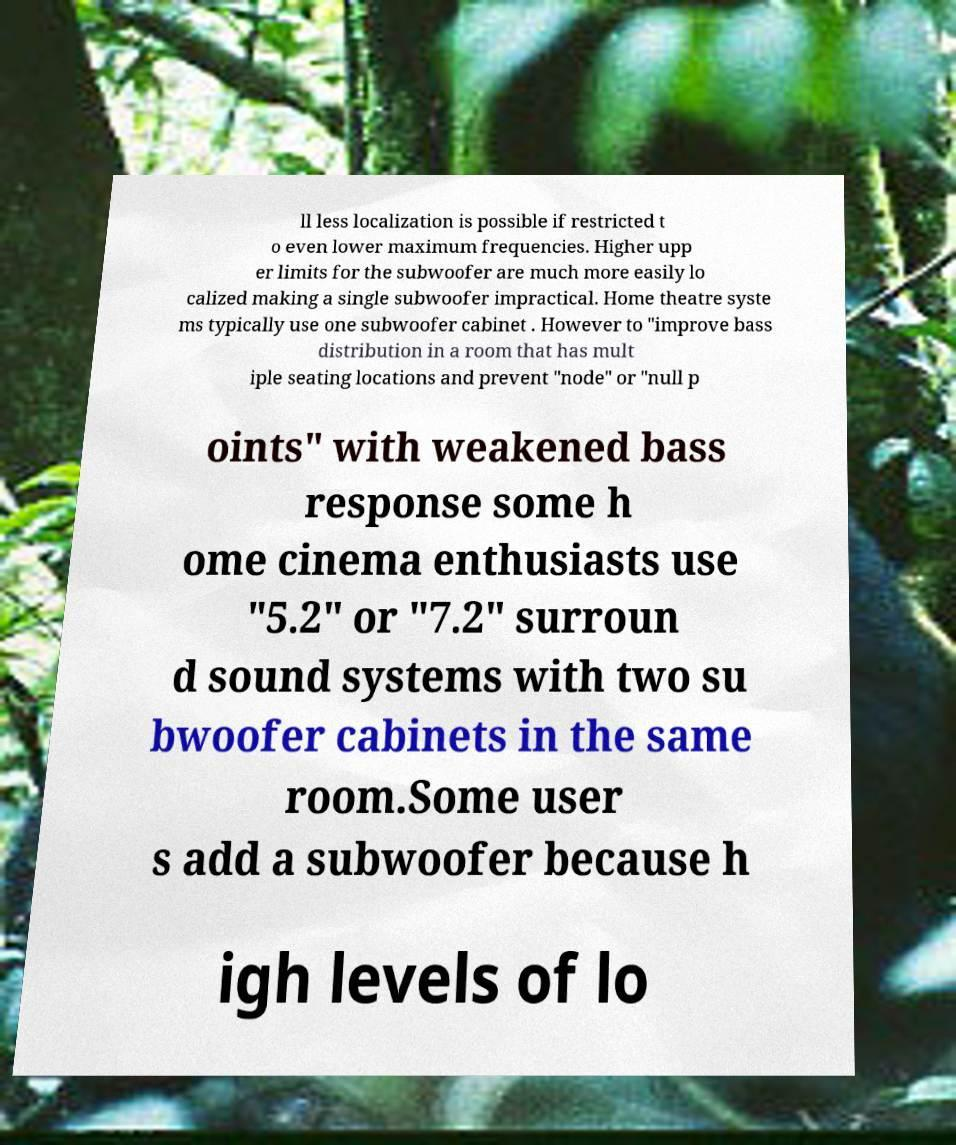What messages or text are displayed in this image? I need them in a readable, typed format. ll less localization is possible if restricted t o even lower maximum frequencies. Higher upp er limits for the subwoofer are much more easily lo calized making a single subwoofer impractical. Home theatre syste ms typically use one subwoofer cabinet . However to "improve bass distribution in a room that has mult iple seating locations and prevent "node" or "null p oints" with weakened bass response some h ome cinema enthusiasts use "5.2" or "7.2" surroun d sound systems with two su bwoofer cabinets in the same room.Some user s add a subwoofer because h igh levels of lo 